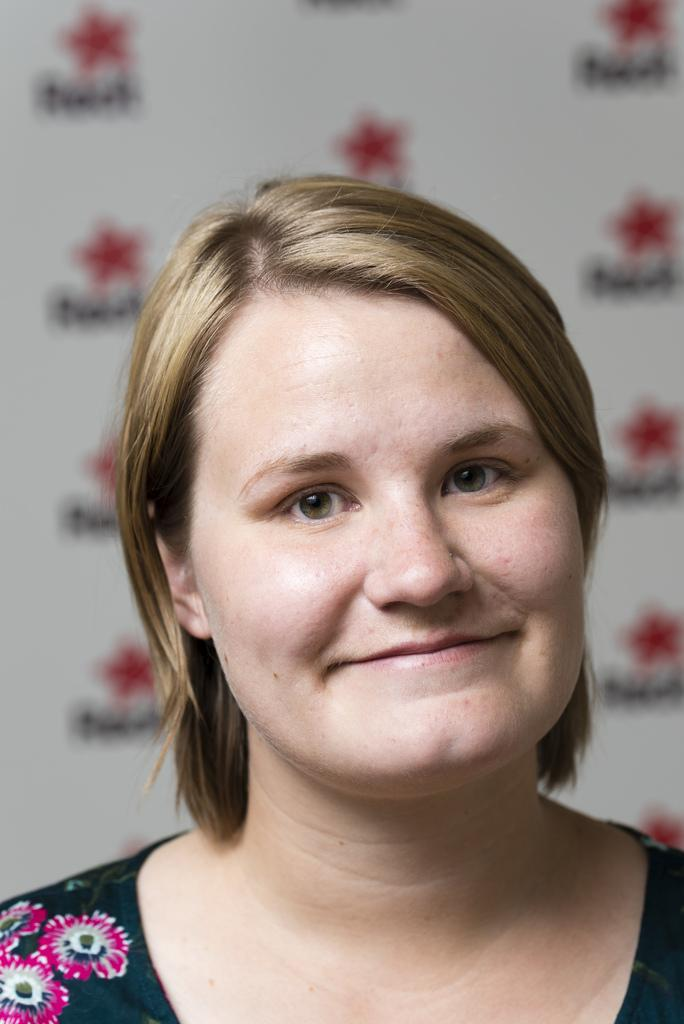Who is present in the image? There is a woman in the image. What is the woman's expression in the image? The woman is smiling in the image. What can be seen in the background of the image? There is a hoarding in the background of the image. What type of brass instrument is the woman playing in the image? There is no brass instrument present in the image; the woman is simply smiling. 